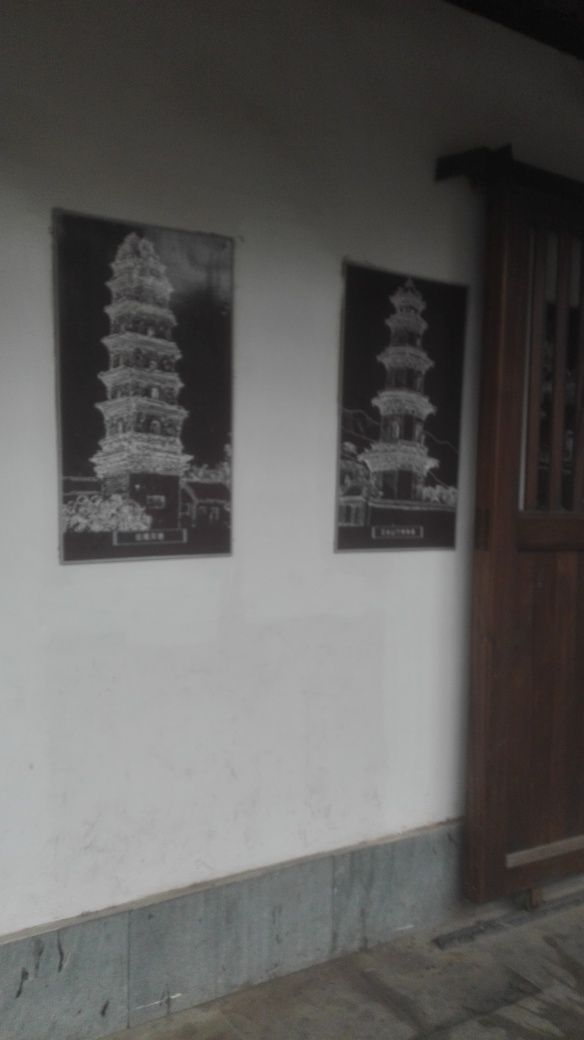Is there any cultural significance to the images depicted in the frames? Pagodas commonly hold significant cultural and historical value in many East Asian societies. They typically serve as religious sites and are often associated with Buddhist traditions. The images in the frames might represent historical or culturally relevant landmarks, potentially used to educate viewers or as a form of artistic homage. 